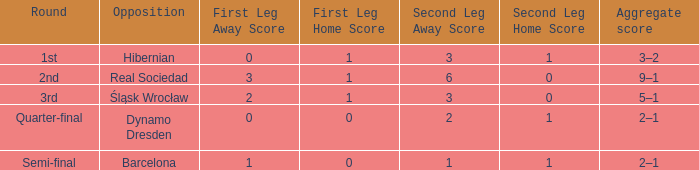Who were the opposition in the quarter-final? Dynamo Dresden. Give me the full table as a dictionary. {'header': ['Round', 'Opposition', 'First Leg Away Score', 'First Leg Home Score', 'Second Leg Away Score', 'Second Leg Home Score', 'Aggregate score'], 'rows': [['1st', 'Hibernian', '0', '1', '3', '1', '3–2'], ['2nd', 'Real Sociedad', '3', '1', '6', '0', '9–1'], ['3rd', 'Śląsk Wrocław', '2', '1', '3', '0', '5–1'], ['Quarter-final', 'Dynamo Dresden', '0', '0', '2', '1', '2–1'], ['Semi-final', 'Barcelona', '1', '0', '1', '1', '2–1']]} 